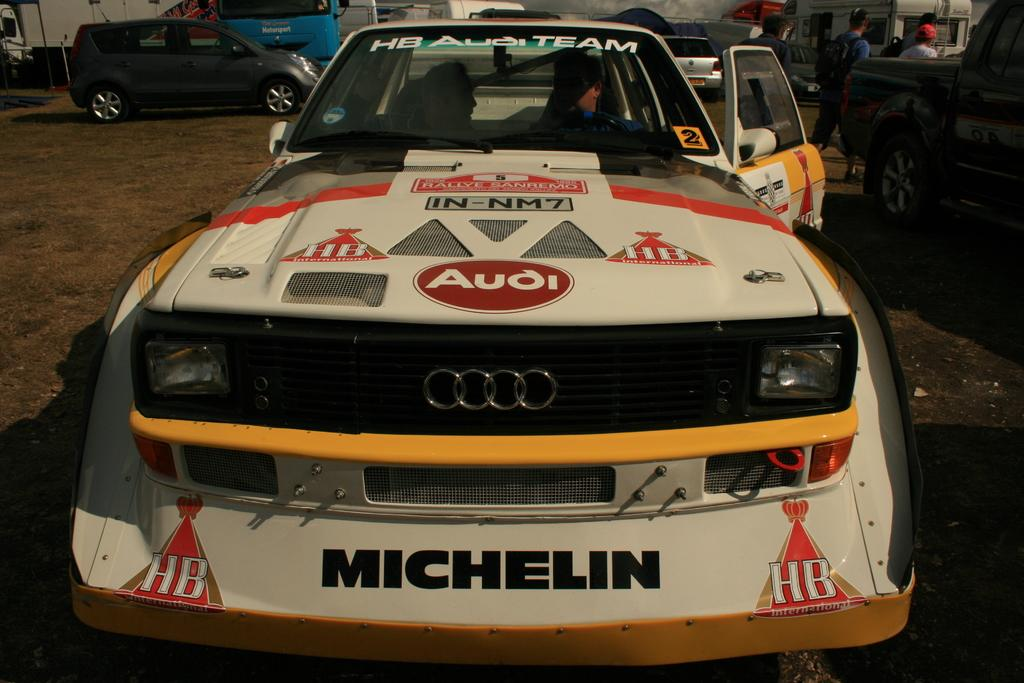<image>
Write a terse but informative summary of the picture. An Audi race car sits outside with the driver door ajar. 